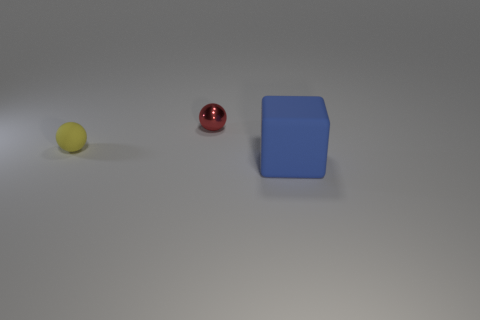Is the blue object made of the same material as the small object right of the tiny yellow rubber object?
Keep it short and to the point. No. Are there an equal number of yellow matte balls that are behind the tiny yellow rubber ball and tiny rubber things?
Offer a very short reply. No. The matte object that is behind the big blue block is what color?
Ensure brevity in your answer.  Yellow. Is there any other thing that is the same size as the blue block?
Offer a very short reply. No. There is a sphere that is behind the yellow ball; is its size the same as the rubber sphere?
Your response must be concise. Yes. What material is the large blue object in front of the yellow rubber ball?
Your response must be concise. Rubber. Is there any other thing that has the same shape as the blue rubber object?
Make the answer very short. No. What number of matte objects are tiny objects or big things?
Provide a short and direct response. 2. Is the number of small red things that are on the right side of the red metal object less than the number of tiny red matte objects?
Offer a very short reply. No. What shape is the thing right of the sphere that is behind the matte thing behind the large blue rubber block?
Your answer should be very brief. Cube. 